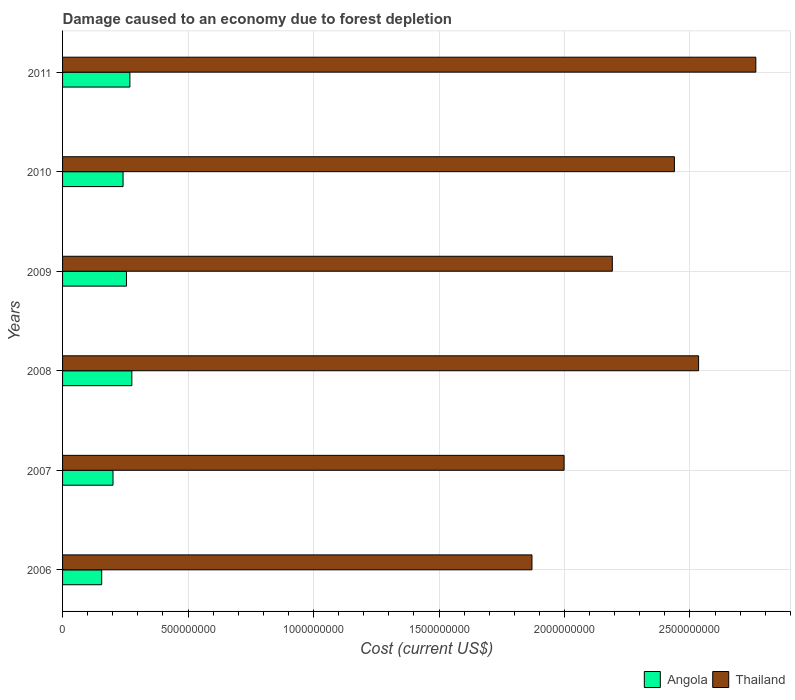How many groups of bars are there?
Give a very brief answer. 6. Are the number of bars per tick equal to the number of legend labels?
Give a very brief answer. Yes. How many bars are there on the 5th tick from the top?
Your response must be concise. 2. In how many cases, is the number of bars for a given year not equal to the number of legend labels?
Provide a succinct answer. 0. What is the cost of damage caused due to forest depletion in Thailand in 2006?
Offer a very short reply. 1.87e+09. Across all years, what is the maximum cost of damage caused due to forest depletion in Angola?
Provide a succinct answer. 2.76e+08. Across all years, what is the minimum cost of damage caused due to forest depletion in Angola?
Offer a very short reply. 1.56e+08. In which year was the cost of damage caused due to forest depletion in Thailand maximum?
Offer a very short reply. 2011. In which year was the cost of damage caused due to forest depletion in Thailand minimum?
Make the answer very short. 2006. What is the total cost of damage caused due to forest depletion in Angola in the graph?
Your answer should be compact. 1.40e+09. What is the difference between the cost of damage caused due to forest depletion in Thailand in 2008 and that in 2009?
Offer a terse response. 3.44e+08. What is the difference between the cost of damage caused due to forest depletion in Thailand in 2009 and the cost of damage caused due to forest depletion in Angola in 2011?
Offer a terse response. 1.92e+09. What is the average cost of damage caused due to forest depletion in Thailand per year?
Your answer should be compact. 2.30e+09. In the year 2008, what is the difference between the cost of damage caused due to forest depletion in Angola and cost of damage caused due to forest depletion in Thailand?
Provide a succinct answer. -2.26e+09. What is the ratio of the cost of damage caused due to forest depletion in Thailand in 2006 to that in 2010?
Your answer should be compact. 0.77. Is the difference between the cost of damage caused due to forest depletion in Angola in 2009 and 2011 greater than the difference between the cost of damage caused due to forest depletion in Thailand in 2009 and 2011?
Provide a succinct answer. Yes. What is the difference between the highest and the second highest cost of damage caused due to forest depletion in Angola?
Provide a succinct answer. 7.76e+06. What is the difference between the highest and the lowest cost of damage caused due to forest depletion in Angola?
Your response must be concise. 1.20e+08. In how many years, is the cost of damage caused due to forest depletion in Angola greater than the average cost of damage caused due to forest depletion in Angola taken over all years?
Your answer should be compact. 4. Is the sum of the cost of damage caused due to forest depletion in Thailand in 2010 and 2011 greater than the maximum cost of damage caused due to forest depletion in Angola across all years?
Provide a short and direct response. Yes. What does the 2nd bar from the top in 2010 represents?
Your answer should be compact. Angola. What does the 1st bar from the bottom in 2010 represents?
Keep it short and to the point. Angola. How many years are there in the graph?
Your answer should be compact. 6. Does the graph contain any zero values?
Provide a short and direct response. No. Does the graph contain grids?
Your response must be concise. Yes. How many legend labels are there?
Make the answer very short. 2. How are the legend labels stacked?
Offer a terse response. Horizontal. What is the title of the graph?
Provide a short and direct response. Damage caused to an economy due to forest depletion. Does "Botswana" appear as one of the legend labels in the graph?
Give a very brief answer. No. What is the label or title of the X-axis?
Provide a succinct answer. Cost (current US$). What is the label or title of the Y-axis?
Provide a short and direct response. Years. What is the Cost (current US$) in Angola in 2006?
Offer a terse response. 1.56e+08. What is the Cost (current US$) of Thailand in 2006?
Ensure brevity in your answer.  1.87e+09. What is the Cost (current US$) of Angola in 2007?
Offer a terse response. 2.01e+08. What is the Cost (current US$) in Thailand in 2007?
Your response must be concise. 2.00e+09. What is the Cost (current US$) in Angola in 2008?
Provide a short and direct response. 2.76e+08. What is the Cost (current US$) in Thailand in 2008?
Your response must be concise. 2.53e+09. What is the Cost (current US$) in Angola in 2009?
Your response must be concise. 2.55e+08. What is the Cost (current US$) of Thailand in 2009?
Offer a very short reply. 2.19e+09. What is the Cost (current US$) of Angola in 2010?
Offer a terse response. 2.41e+08. What is the Cost (current US$) of Thailand in 2010?
Ensure brevity in your answer.  2.44e+09. What is the Cost (current US$) in Angola in 2011?
Your answer should be compact. 2.68e+08. What is the Cost (current US$) of Thailand in 2011?
Provide a short and direct response. 2.76e+09. Across all years, what is the maximum Cost (current US$) in Angola?
Your response must be concise. 2.76e+08. Across all years, what is the maximum Cost (current US$) in Thailand?
Ensure brevity in your answer.  2.76e+09. Across all years, what is the minimum Cost (current US$) of Angola?
Your answer should be very brief. 1.56e+08. Across all years, what is the minimum Cost (current US$) in Thailand?
Your answer should be compact. 1.87e+09. What is the total Cost (current US$) in Angola in the graph?
Give a very brief answer. 1.40e+09. What is the total Cost (current US$) in Thailand in the graph?
Your answer should be very brief. 1.38e+1. What is the difference between the Cost (current US$) of Angola in 2006 and that in 2007?
Offer a terse response. -4.52e+07. What is the difference between the Cost (current US$) of Thailand in 2006 and that in 2007?
Offer a very short reply. -1.28e+08. What is the difference between the Cost (current US$) of Angola in 2006 and that in 2008?
Your answer should be very brief. -1.20e+08. What is the difference between the Cost (current US$) of Thailand in 2006 and that in 2008?
Offer a terse response. -6.64e+08. What is the difference between the Cost (current US$) of Angola in 2006 and that in 2009?
Make the answer very short. -9.88e+07. What is the difference between the Cost (current US$) in Thailand in 2006 and that in 2009?
Your response must be concise. -3.20e+08. What is the difference between the Cost (current US$) in Angola in 2006 and that in 2010?
Your response must be concise. -8.52e+07. What is the difference between the Cost (current US$) of Thailand in 2006 and that in 2010?
Offer a terse response. -5.68e+08. What is the difference between the Cost (current US$) of Angola in 2006 and that in 2011?
Give a very brief answer. -1.12e+08. What is the difference between the Cost (current US$) of Thailand in 2006 and that in 2011?
Provide a short and direct response. -8.92e+08. What is the difference between the Cost (current US$) of Angola in 2007 and that in 2008?
Give a very brief answer. -7.50e+07. What is the difference between the Cost (current US$) of Thailand in 2007 and that in 2008?
Make the answer very short. -5.36e+08. What is the difference between the Cost (current US$) in Angola in 2007 and that in 2009?
Provide a short and direct response. -5.36e+07. What is the difference between the Cost (current US$) of Thailand in 2007 and that in 2009?
Your answer should be very brief. -1.92e+08. What is the difference between the Cost (current US$) in Angola in 2007 and that in 2010?
Give a very brief answer. -4.00e+07. What is the difference between the Cost (current US$) of Thailand in 2007 and that in 2010?
Keep it short and to the point. -4.40e+08. What is the difference between the Cost (current US$) of Angola in 2007 and that in 2011?
Provide a succinct answer. -6.72e+07. What is the difference between the Cost (current US$) in Thailand in 2007 and that in 2011?
Provide a succinct answer. -7.64e+08. What is the difference between the Cost (current US$) of Angola in 2008 and that in 2009?
Keep it short and to the point. 2.14e+07. What is the difference between the Cost (current US$) of Thailand in 2008 and that in 2009?
Offer a very short reply. 3.44e+08. What is the difference between the Cost (current US$) in Angola in 2008 and that in 2010?
Offer a very short reply. 3.50e+07. What is the difference between the Cost (current US$) of Thailand in 2008 and that in 2010?
Your answer should be very brief. 9.63e+07. What is the difference between the Cost (current US$) in Angola in 2008 and that in 2011?
Offer a terse response. 7.76e+06. What is the difference between the Cost (current US$) of Thailand in 2008 and that in 2011?
Offer a terse response. -2.28e+08. What is the difference between the Cost (current US$) of Angola in 2009 and that in 2010?
Your response must be concise. 1.36e+07. What is the difference between the Cost (current US$) in Thailand in 2009 and that in 2010?
Provide a succinct answer. -2.47e+08. What is the difference between the Cost (current US$) in Angola in 2009 and that in 2011?
Your answer should be very brief. -1.36e+07. What is the difference between the Cost (current US$) in Thailand in 2009 and that in 2011?
Provide a succinct answer. -5.72e+08. What is the difference between the Cost (current US$) of Angola in 2010 and that in 2011?
Your answer should be compact. -2.72e+07. What is the difference between the Cost (current US$) of Thailand in 2010 and that in 2011?
Keep it short and to the point. -3.24e+08. What is the difference between the Cost (current US$) of Angola in 2006 and the Cost (current US$) of Thailand in 2007?
Offer a terse response. -1.84e+09. What is the difference between the Cost (current US$) in Angola in 2006 and the Cost (current US$) in Thailand in 2008?
Ensure brevity in your answer.  -2.38e+09. What is the difference between the Cost (current US$) of Angola in 2006 and the Cost (current US$) of Thailand in 2009?
Keep it short and to the point. -2.03e+09. What is the difference between the Cost (current US$) of Angola in 2006 and the Cost (current US$) of Thailand in 2010?
Your answer should be compact. -2.28e+09. What is the difference between the Cost (current US$) of Angola in 2006 and the Cost (current US$) of Thailand in 2011?
Offer a very short reply. -2.61e+09. What is the difference between the Cost (current US$) of Angola in 2007 and the Cost (current US$) of Thailand in 2008?
Keep it short and to the point. -2.33e+09. What is the difference between the Cost (current US$) of Angola in 2007 and the Cost (current US$) of Thailand in 2009?
Ensure brevity in your answer.  -1.99e+09. What is the difference between the Cost (current US$) of Angola in 2007 and the Cost (current US$) of Thailand in 2010?
Keep it short and to the point. -2.24e+09. What is the difference between the Cost (current US$) of Angola in 2007 and the Cost (current US$) of Thailand in 2011?
Keep it short and to the point. -2.56e+09. What is the difference between the Cost (current US$) in Angola in 2008 and the Cost (current US$) in Thailand in 2009?
Your answer should be compact. -1.91e+09. What is the difference between the Cost (current US$) in Angola in 2008 and the Cost (current US$) in Thailand in 2010?
Your answer should be very brief. -2.16e+09. What is the difference between the Cost (current US$) in Angola in 2008 and the Cost (current US$) in Thailand in 2011?
Your answer should be very brief. -2.49e+09. What is the difference between the Cost (current US$) of Angola in 2009 and the Cost (current US$) of Thailand in 2010?
Keep it short and to the point. -2.18e+09. What is the difference between the Cost (current US$) of Angola in 2009 and the Cost (current US$) of Thailand in 2011?
Offer a terse response. -2.51e+09. What is the difference between the Cost (current US$) of Angola in 2010 and the Cost (current US$) of Thailand in 2011?
Offer a terse response. -2.52e+09. What is the average Cost (current US$) of Angola per year?
Your answer should be compact. 2.33e+08. What is the average Cost (current US$) of Thailand per year?
Offer a terse response. 2.30e+09. In the year 2006, what is the difference between the Cost (current US$) in Angola and Cost (current US$) in Thailand?
Your response must be concise. -1.71e+09. In the year 2007, what is the difference between the Cost (current US$) in Angola and Cost (current US$) in Thailand?
Your answer should be compact. -1.80e+09. In the year 2008, what is the difference between the Cost (current US$) of Angola and Cost (current US$) of Thailand?
Offer a very short reply. -2.26e+09. In the year 2009, what is the difference between the Cost (current US$) in Angola and Cost (current US$) in Thailand?
Provide a succinct answer. -1.94e+09. In the year 2010, what is the difference between the Cost (current US$) in Angola and Cost (current US$) in Thailand?
Provide a succinct answer. -2.20e+09. In the year 2011, what is the difference between the Cost (current US$) of Angola and Cost (current US$) of Thailand?
Your answer should be very brief. -2.49e+09. What is the ratio of the Cost (current US$) in Angola in 2006 to that in 2007?
Provide a succinct answer. 0.78. What is the ratio of the Cost (current US$) in Thailand in 2006 to that in 2007?
Offer a terse response. 0.94. What is the ratio of the Cost (current US$) of Angola in 2006 to that in 2008?
Your answer should be very brief. 0.56. What is the ratio of the Cost (current US$) in Thailand in 2006 to that in 2008?
Ensure brevity in your answer.  0.74. What is the ratio of the Cost (current US$) of Angola in 2006 to that in 2009?
Your answer should be compact. 0.61. What is the ratio of the Cost (current US$) in Thailand in 2006 to that in 2009?
Offer a very short reply. 0.85. What is the ratio of the Cost (current US$) of Angola in 2006 to that in 2010?
Offer a very short reply. 0.65. What is the ratio of the Cost (current US$) of Thailand in 2006 to that in 2010?
Your response must be concise. 0.77. What is the ratio of the Cost (current US$) of Angola in 2006 to that in 2011?
Give a very brief answer. 0.58. What is the ratio of the Cost (current US$) of Thailand in 2006 to that in 2011?
Ensure brevity in your answer.  0.68. What is the ratio of the Cost (current US$) of Angola in 2007 to that in 2008?
Your response must be concise. 0.73. What is the ratio of the Cost (current US$) in Thailand in 2007 to that in 2008?
Your answer should be compact. 0.79. What is the ratio of the Cost (current US$) in Angola in 2007 to that in 2009?
Provide a short and direct response. 0.79. What is the ratio of the Cost (current US$) of Thailand in 2007 to that in 2009?
Keep it short and to the point. 0.91. What is the ratio of the Cost (current US$) in Angola in 2007 to that in 2010?
Provide a succinct answer. 0.83. What is the ratio of the Cost (current US$) in Thailand in 2007 to that in 2010?
Your answer should be very brief. 0.82. What is the ratio of the Cost (current US$) of Angola in 2007 to that in 2011?
Your answer should be compact. 0.75. What is the ratio of the Cost (current US$) of Thailand in 2007 to that in 2011?
Your answer should be compact. 0.72. What is the ratio of the Cost (current US$) of Angola in 2008 to that in 2009?
Your answer should be compact. 1.08. What is the ratio of the Cost (current US$) in Thailand in 2008 to that in 2009?
Provide a short and direct response. 1.16. What is the ratio of the Cost (current US$) in Angola in 2008 to that in 2010?
Offer a very short reply. 1.15. What is the ratio of the Cost (current US$) in Thailand in 2008 to that in 2010?
Your response must be concise. 1.04. What is the ratio of the Cost (current US$) of Angola in 2008 to that in 2011?
Give a very brief answer. 1.03. What is the ratio of the Cost (current US$) in Thailand in 2008 to that in 2011?
Make the answer very short. 0.92. What is the ratio of the Cost (current US$) in Angola in 2009 to that in 2010?
Provide a succinct answer. 1.06. What is the ratio of the Cost (current US$) of Thailand in 2009 to that in 2010?
Your answer should be very brief. 0.9. What is the ratio of the Cost (current US$) of Angola in 2009 to that in 2011?
Your answer should be very brief. 0.95. What is the ratio of the Cost (current US$) in Thailand in 2009 to that in 2011?
Offer a terse response. 0.79. What is the ratio of the Cost (current US$) in Angola in 2010 to that in 2011?
Provide a succinct answer. 0.9. What is the ratio of the Cost (current US$) in Thailand in 2010 to that in 2011?
Your answer should be very brief. 0.88. What is the difference between the highest and the second highest Cost (current US$) of Angola?
Offer a terse response. 7.76e+06. What is the difference between the highest and the second highest Cost (current US$) of Thailand?
Make the answer very short. 2.28e+08. What is the difference between the highest and the lowest Cost (current US$) in Angola?
Offer a very short reply. 1.20e+08. What is the difference between the highest and the lowest Cost (current US$) of Thailand?
Your answer should be very brief. 8.92e+08. 